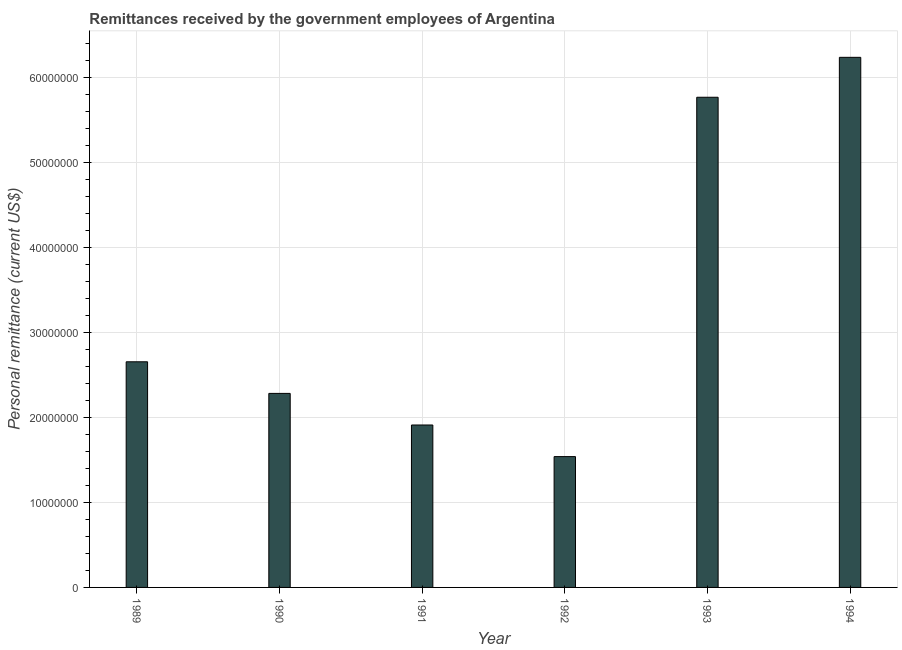Does the graph contain any zero values?
Ensure brevity in your answer.  No. Does the graph contain grids?
Your answer should be compact. Yes. What is the title of the graph?
Offer a terse response. Remittances received by the government employees of Argentina. What is the label or title of the X-axis?
Your response must be concise. Year. What is the label or title of the Y-axis?
Ensure brevity in your answer.  Personal remittance (current US$). What is the personal remittances in 1993?
Provide a short and direct response. 5.77e+07. Across all years, what is the maximum personal remittances?
Offer a very short reply. 6.24e+07. Across all years, what is the minimum personal remittances?
Provide a succinct answer. 1.54e+07. In which year was the personal remittances minimum?
Your response must be concise. 1992. What is the sum of the personal remittances?
Make the answer very short. 2.04e+08. What is the difference between the personal remittances in 1992 and 1994?
Your answer should be compact. -4.70e+07. What is the average personal remittances per year?
Keep it short and to the point. 3.40e+07. What is the median personal remittances?
Make the answer very short. 2.47e+07. Do a majority of the years between 1991 and 1994 (inclusive) have personal remittances greater than 36000000 US$?
Offer a very short reply. No. What is the ratio of the personal remittances in 1989 to that in 1994?
Offer a terse response. 0.43. Is the personal remittances in 1990 less than that in 1991?
Make the answer very short. No. What is the difference between the highest and the second highest personal remittances?
Provide a succinct answer. 4.70e+06. What is the difference between the highest and the lowest personal remittances?
Your answer should be very brief. 4.70e+07. In how many years, is the personal remittances greater than the average personal remittances taken over all years?
Ensure brevity in your answer.  2. How many bars are there?
Your response must be concise. 6. Are all the bars in the graph horizontal?
Make the answer very short. No. How many years are there in the graph?
Offer a terse response. 6. What is the difference between two consecutive major ticks on the Y-axis?
Your answer should be very brief. 1.00e+07. What is the Personal remittance (current US$) of 1989?
Provide a short and direct response. 2.66e+07. What is the Personal remittance (current US$) of 1990?
Offer a terse response. 2.28e+07. What is the Personal remittance (current US$) of 1991?
Provide a succinct answer. 1.91e+07. What is the Personal remittance (current US$) of 1992?
Your answer should be very brief. 1.54e+07. What is the Personal remittance (current US$) in 1993?
Your answer should be compact. 5.77e+07. What is the Personal remittance (current US$) in 1994?
Offer a terse response. 6.24e+07. What is the difference between the Personal remittance (current US$) in 1989 and 1990?
Your response must be concise. 3.72e+06. What is the difference between the Personal remittance (current US$) in 1989 and 1991?
Your response must be concise. 7.44e+06. What is the difference between the Personal remittance (current US$) in 1989 and 1992?
Give a very brief answer. 1.12e+07. What is the difference between the Personal remittance (current US$) in 1989 and 1993?
Offer a terse response. -3.11e+07. What is the difference between the Personal remittance (current US$) in 1989 and 1994?
Ensure brevity in your answer.  -3.58e+07. What is the difference between the Personal remittance (current US$) in 1990 and 1991?
Your answer should be very brief. 3.72e+06. What is the difference between the Personal remittance (current US$) in 1990 and 1992?
Your answer should be compact. 7.44e+06. What is the difference between the Personal remittance (current US$) in 1990 and 1993?
Provide a succinct answer. -3.49e+07. What is the difference between the Personal remittance (current US$) in 1990 and 1994?
Offer a very short reply. -3.96e+07. What is the difference between the Personal remittance (current US$) in 1991 and 1992?
Provide a succinct answer. 3.72e+06. What is the difference between the Personal remittance (current US$) in 1991 and 1993?
Provide a short and direct response. -3.86e+07. What is the difference between the Personal remittance (current US$) in 1991 and 1994?
Provide a short and direct response. -4.33e+07. What is the difference between the Personal remittance (current US$) in 1992 and 1993?
Your response must be concise. -4.23e+07. What is the difference between the Personal remittance (current US$) in 1992 and 1994?
Keep it short and to the point. -4.70e+07. What is the difference between the Personal remittance (current US$) in 1993 and 1994?
Make the answer very short. -4.70e+06. What is the ratio of the Personal remittance (current US$) in 1989 to that in 1990?
Offer a terse response. 1.16. What is the ratio of the Personal remittance (current US$) in 1989 to that in 1991?
Make the answer very short. 1.39. What is the ratio of the Personal remittance (current US$) in 1989 to that in 1992?
Your answer should be compact. 1.73. What is the ratio of the Personal remittance (current US$) in 1989 to that in 1993?
Make the answer very short. 0.46. What is the ratio of the Personal remittance (current US$) in 1989 to that in 1994?
Your answer should be very brief. 0.43. What is the ratio of the Personal remittance (current US$) in 1990 to that in 1991?
Your answer should be compact. 1.2. What is the ratio of the Personal remittance (current US$) in 1990 to that in 1992?
Provide a short and direct response. 1.48. What is the ratio of the Personal remittance (current US$) in 1990 to that in 1993?
Offer a terse response. 0.4. What is the ratio of the Personal remittance (current US$) in 1990 to that in 1994?
Provide a succinct answer. 0.37. What is the ratio of the Personal remittance (current US$) in 1991 to that in 1992?
Make the answer very short. 1.24. What is the ratio of the Personal remittance (current US$) in 1991 to that in 1993?
Give a very brief answer. 0.33. What is the ratio of the Personal remittance (current US$) in 1991 to that in 1994?
Offer a very short reply. 0.31. What is the ratio of the Personal remittance (current US$) in 1992 to that in 1993?
Your response must be concise. 0.27. What is the ratio of the Personal remittance (current US$) in 1992 to that in 1994?
Offer a very short reply. 0.25. What is the ratio of the Personal remittance (current US$) in 1993 to that in 1994?
Provide a succinct answer. 0.93. 